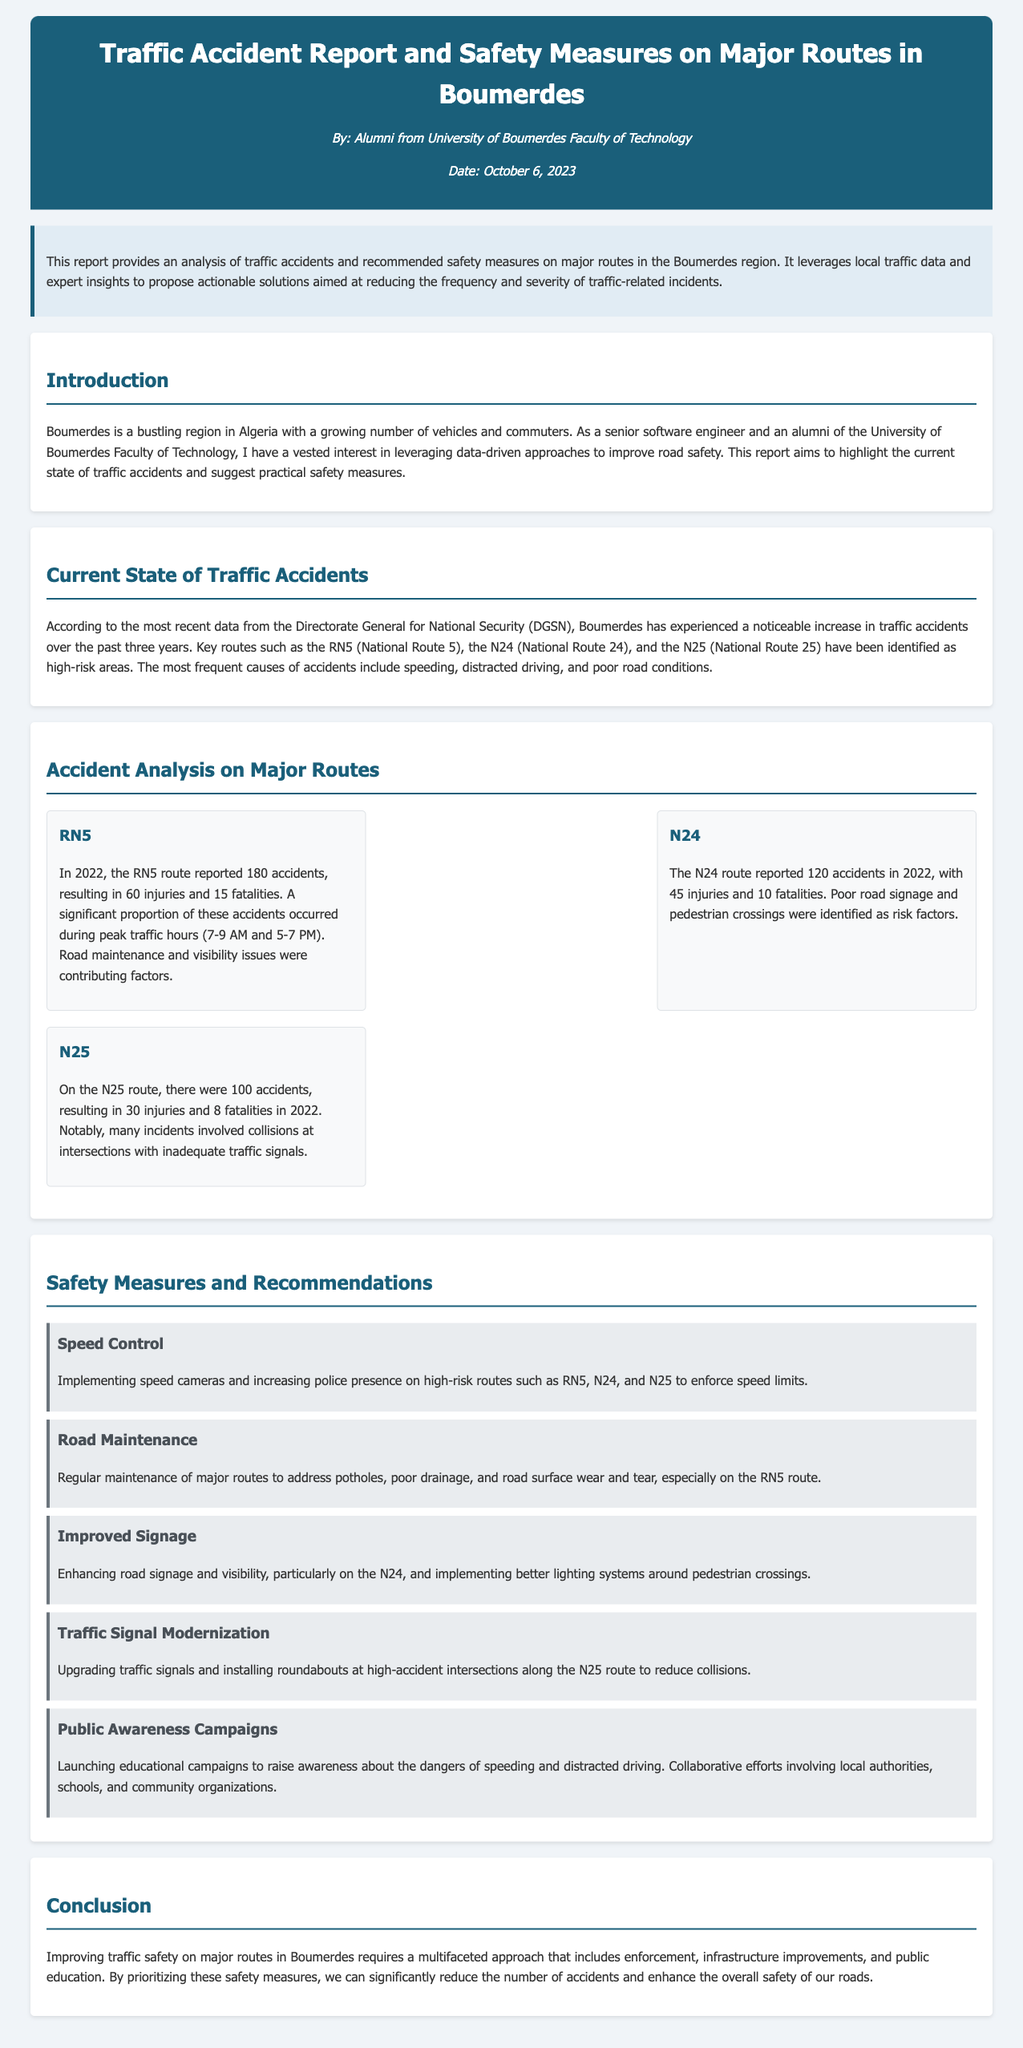What was the date of the report? The report states the date as October 6, 2023.
Answer: October 6, 2023 How many accidents were reported on the RN5 in 2022? The document specifies that RN5 reported 180 accidents in 2022.
Answer: 180 What is one of the frequent causes of accidents mentioned? The report lists speeding as one of the frequent causes of accidents.
Answer: Speeding What safety measure is recommended for N24? The document suggests improving road signage as a safety measure for N24.
Answer: Improved Signage How many injuries were reported on the N25 in 2022? The report mentions 30 injuries on the N25 in 2022.
Answer: 30 Which route had the highest number of fatalities in 2022? According to the report, the RN5 had the highest number of fatalities, with 15.
Answer: RN5 What is the primary recommendation for traffic signals? The document recommends upgrading traffic signals on high-accident intersections.
Answer: Upgrading traffic signals What organization provided the data on traffic accidents? The report identifies the Directorate General for National Security (DGSN) as the source.
Answer: Directorate General for National Security (DGSN) What time was noted for peak traffic hours on the RN5? The report states the peak traffic hours for RN5 as 7-9 AM and 5-7 PM.
Answer: 7-9 AM and 5-7 PM 